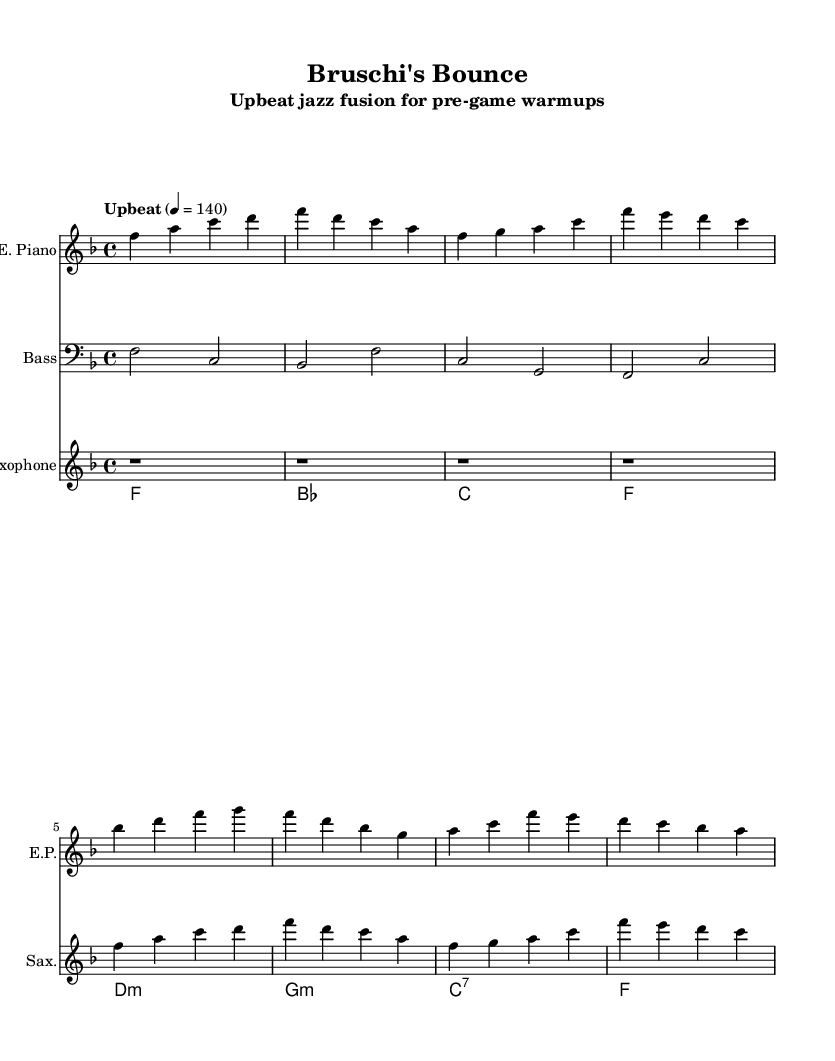What is the key signature of this music? The key signature displayed is F major, which has one flat (B flat). This is identifiable at the beginning of the staff, where a flat sign appears on the B line.
Answer: F major What is the time signature of the piece? The time signature shows 4/4, which is indicated at the beginning. This means there are four beats in each measure and a quarter note receives one beat.
Answer: 4/4 What is the tempo marking for this piece? The tempo marking states "Upbeat" with a metronome marking of 140. This suggests a lively and fast-paced feel to the music, indicated right at the start.
Answer: 140 How many measures does the electric piano part have? The electric piano part has 8 measures. By counting the number of vertical lines (bar lines) in the electric piano staff, we find there are 8 distinct sections each separated by these lines.
Answer: 8 What is the first chord played in the chord progression? The first chord shown in the progression is F major, which can be seen at the start of the chord names section. This chord corresponds with the key signature and is common in the jazz genre.
Answer: F Are there any rests in the saxophone part? Yes, there are rests in the saxophone part. Specifically, the first four measures consist solely of quarter-note rests, which are indicated by the rest symbols on the staff.
Answer: Yes 